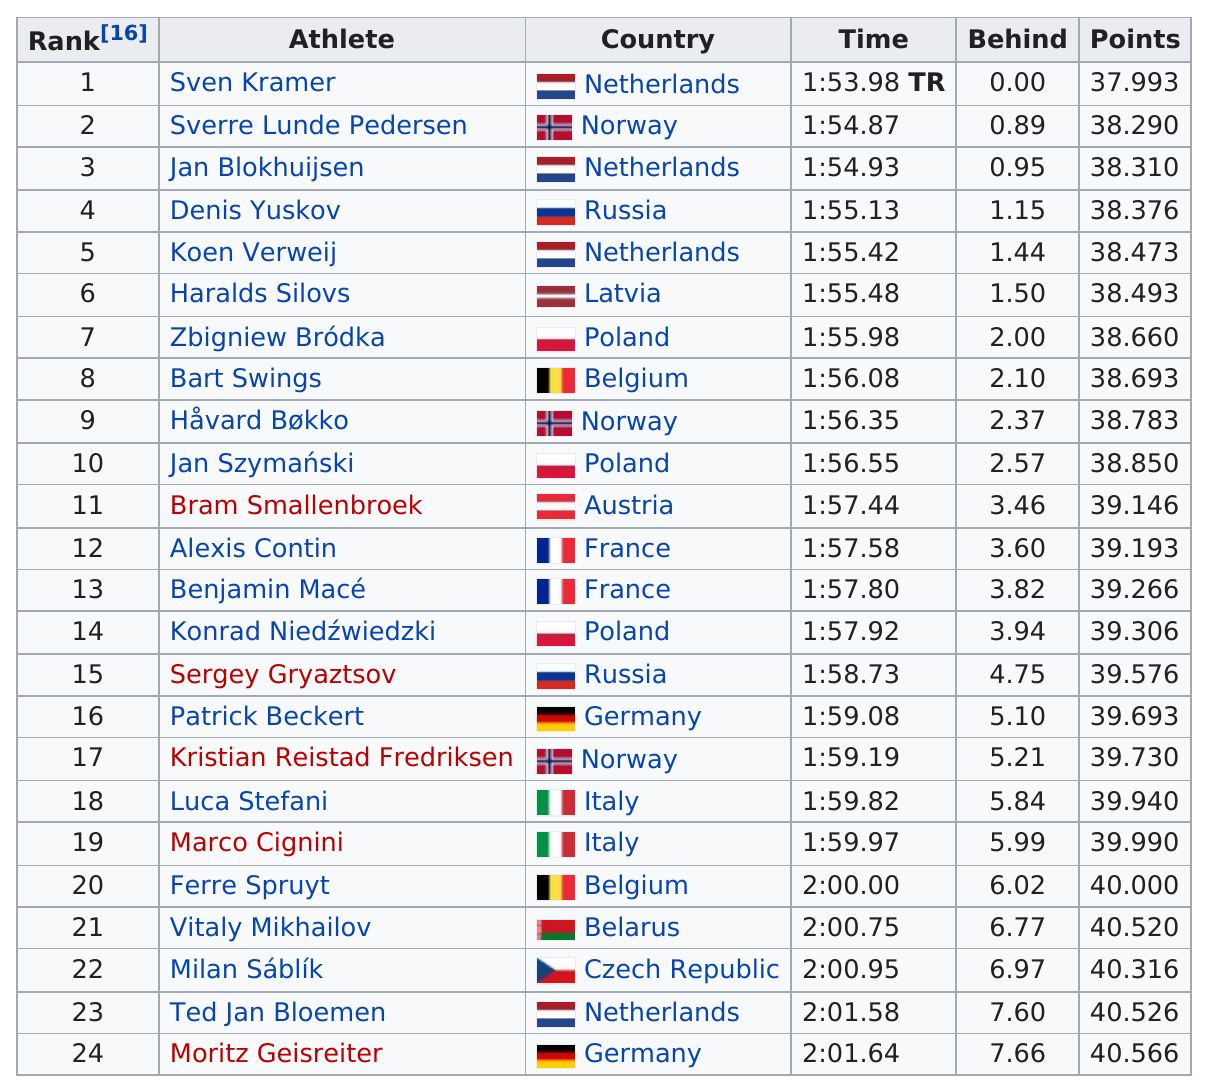Specify some key components in this picture. Lavia is ranked 6, but it is surpassed by the Netherlands in the ranking. There were two competitors from France in the competition. Out of the total number of athletes who have completed the 800m race, three of them have achieved a time below 1:55. The total number of points obtained by the top 5 runners on the list is 191.442... The last-place finisher in the race was Moritz Geisreiter. 